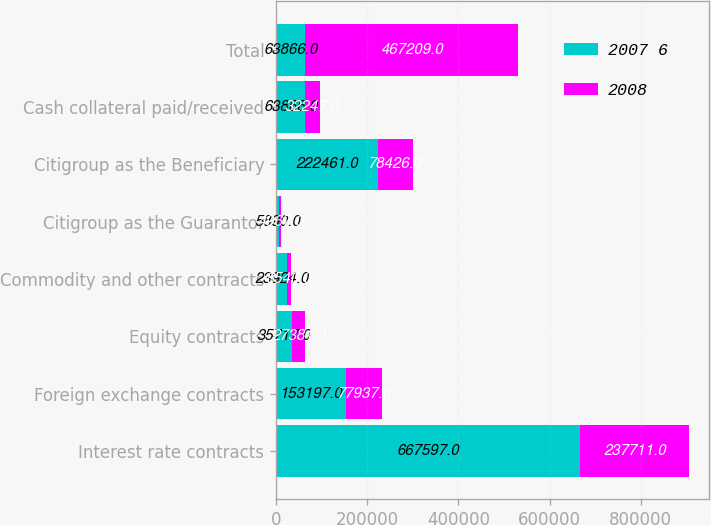Convert chart to OTSL. <chart><loc_0><loc_0><loc_500><loc_500><stacked_bar_chart><ecel><fcel>Interest rate contracts<fcel>Foreign exchange contracts<fcel>Equity contracts<fcel>Commodity and other contracts<fcel>Citigroup as the Guarantor<fcel>Citigroup as the Beneficiary<fcel>Cash collateral paid/received<fcel>Total<nl><fcel>2007 6<fcel>667597<fcel>153197<fcel>35717<fcel>23924<fcel>5890<fcel>222461<fcel>63866<fcel>63866<nl><fcel>2008<fcel>237711<fcel>77937<fcel>27381<fcel>8540<fcel>4967<fcel>78426<fcel>32247<fcel>467209<nl></chart> 